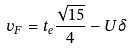Convert formula to latex. <formula><loc_0><loc_0><loc_500><loc_500>v _ { F } = t _ { e } \frac { \sqrt { 1 5 } } 4 - U \delta</formula> 